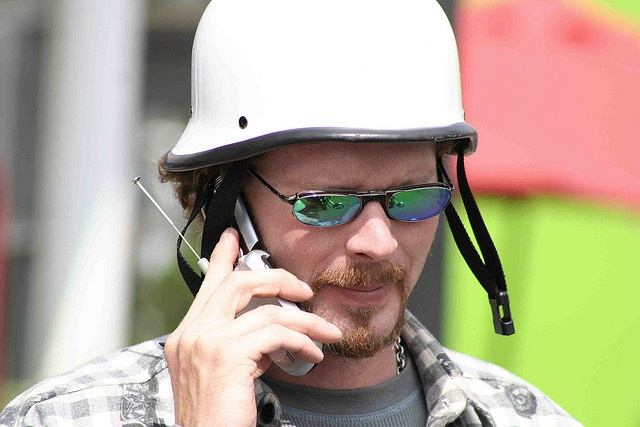Describe the objects in this image and their specific colors. I can see people in gray, white, black, and brown tones and cell phone in gray, black, darkgray, and lightgray tones in this image. 